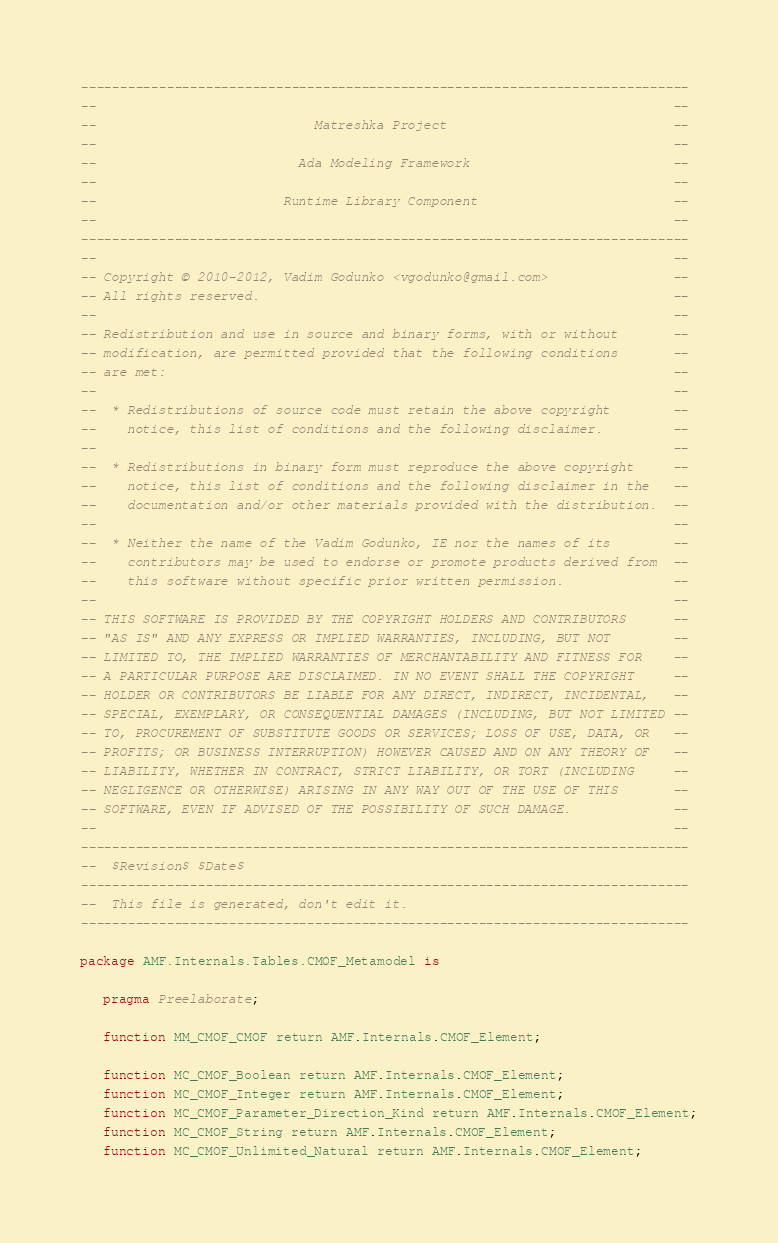Convert code to text. <code><loc_0><loc_0><loc_500><loc_500><_Ada_>------------------------------------------------------------------------------
--                                                                          --
--                            Matreshka Project                             --
--                                                                          --
--                          Ada Modeling Framework                          --
--                                                                          --
--                        Runtime Library Component                         --
--                                                                          --
------------------------------------------------------------------------------
--                                                                          --
-- Copyright © 2010-2012, Vadim Godunko <vgodunko@gmail.com>                --
-- All rights reserved.                                                     --
--                                                                          --
-- Redistribution and use in source and binary forms, with or without       --
-- modification, are permitted provided that the following conditions       --
-- are met:                                                                 --
--                                                                          --
--  * Redistributions of source code must retain the above copyright        --
--    notice, this list of conditions and the following disclaimer.         --
--                                                                          --
--  * Redistributions in binary form must reproduce the above copyright     --
--    notice, this list of conditions and the following disclaimer in the   --
--    documentation and/or other materials provided with the distribution.  --
--                                                                          --
--  * Neither the name of the Vadim Godunko, IE nor the names of its        --
--    contributors may be used to endorse or promote products derived from  --
--    this software without specific prior written permission.              --
--                                                                          --
-- THIS SOFTWARE IS PROVIDED BY THE COPYRIGHT HOLDERS AND CONTRIBUTORS      --
-- "AS IS" AND ANY EXPRESS OR IMPLIED WARRANTIES, INCLUDING, BUT NOT        --
-- LIMITED TO, THE IMPLIED WARRANTIES OF MERCHANTABILITY AND FITNESS FOR    --
-- A PARTICULAR PURPOSE ARE DISCLAIMED. IN NO EVENT SHALL THE COPYRIGHT     --
-- HOLDER OR CONTRIBUTORS BE LIABLE FOR ANY DIRECT, INDIRECT, INCIDENTAL,   --
-- SPECIAL, EXEMPLARY, OR CONSEQUENTIAL DAMAGES (INCLUDING, BUT NOT LIMITED --
-- TO, PROCUREMENT OF SUBSTITUTE GOODS OR SERVICES; LOSS OF USE, DATA, OR   --
-- PROFITS; OR BUSINESS INTERRUPTION) HOWEVER CAUSED AND ON ANY THEORY OF   --
-- LIABILITY, WHETHER IN CONTRACT, STRICT LIABILITY, OR TORT (INCLUDING     --
-- NEGLIGENCE OR OTHERWISE) ARISING IN ANY WAY OUT OF THE USE OF THIS       --
-- SOFTWARE, EVEN IF ADVISED OF THE POSSIBILITY OF SUCH DAMAGE.             --
--                                                                          --
------------------------------------------------------------------------------
--  $Revision$ $Date$
------------------------------------------------------------------------------
--  This file is generated, don't edit it.
------------------------------------------------------------------------------

package AMF.Internals.Tables.CMOF_Metamodel is

   pragma Preelaborate;

   function MM_CMOF_CMOF return AMF.Internals.CMOF_Element;

   function MC_CMOF_Boolean return AMF.Internals.CMOF_Element;
   function MC_CMOF_Integer return AMF.Internals.CMOF_Element;
   function MC_CMOF_Parameter_Direction_Kind return AMF.Internals.CMOF_Element;
   function MC_CMOF_String return AMF.Internals.CMOF_Element;
   function MC_CMOF_Unlimited_Natural return AMF.Internals.CMOF_Element;</code> 